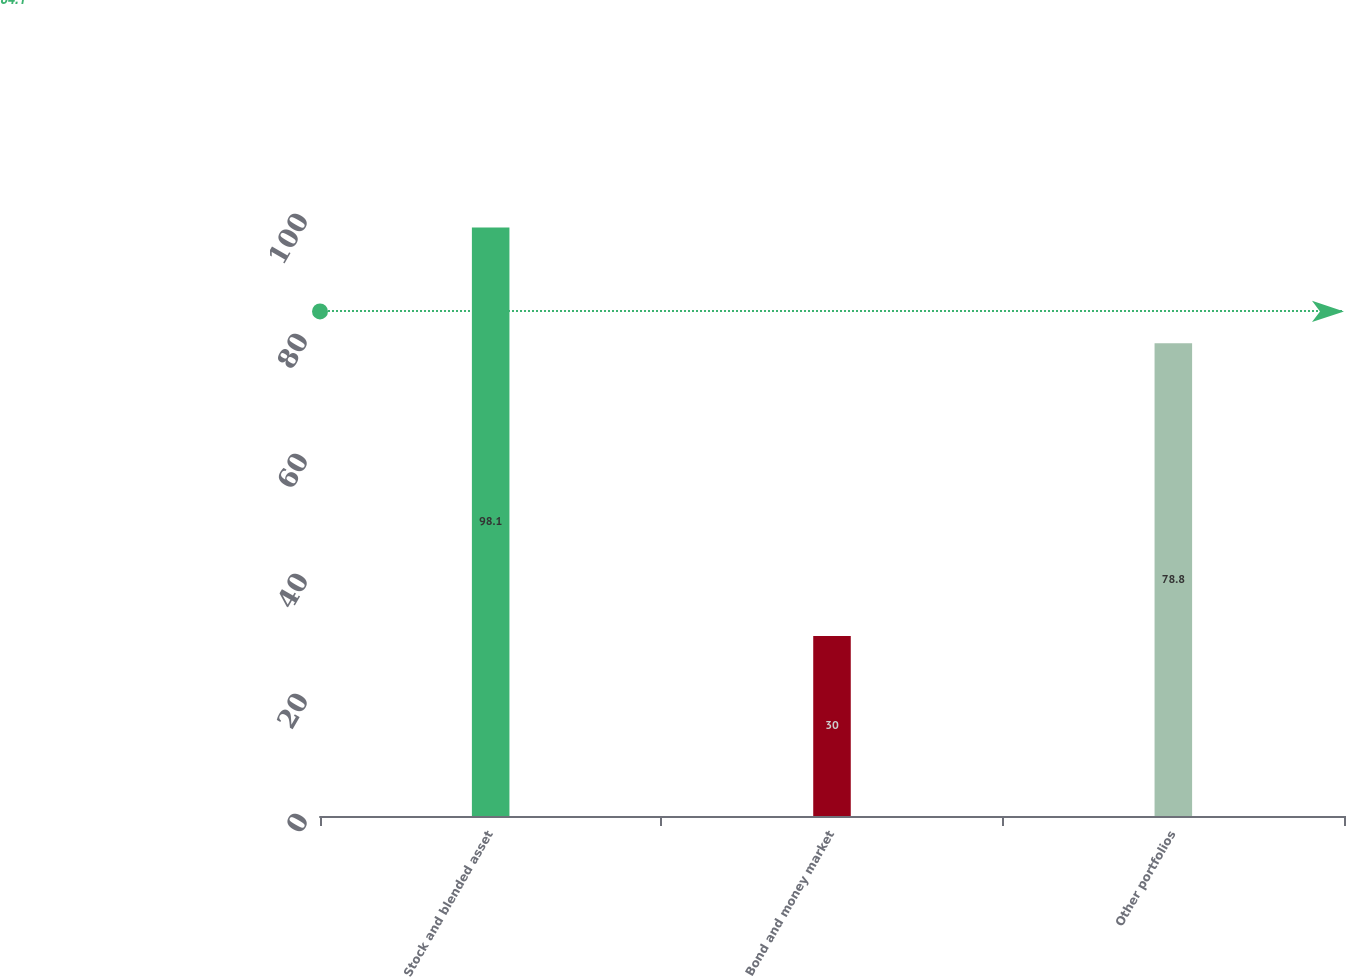Convert chart. <chart><loc_0><loc_0><loc_500><loc_500><bar_chart><fcel>Stock and blended asset<fcel>Bond and money market<fcel>Other portfolios<nl><fcel>98.1<fcel>30<fcel>78.8<nl></chart> 